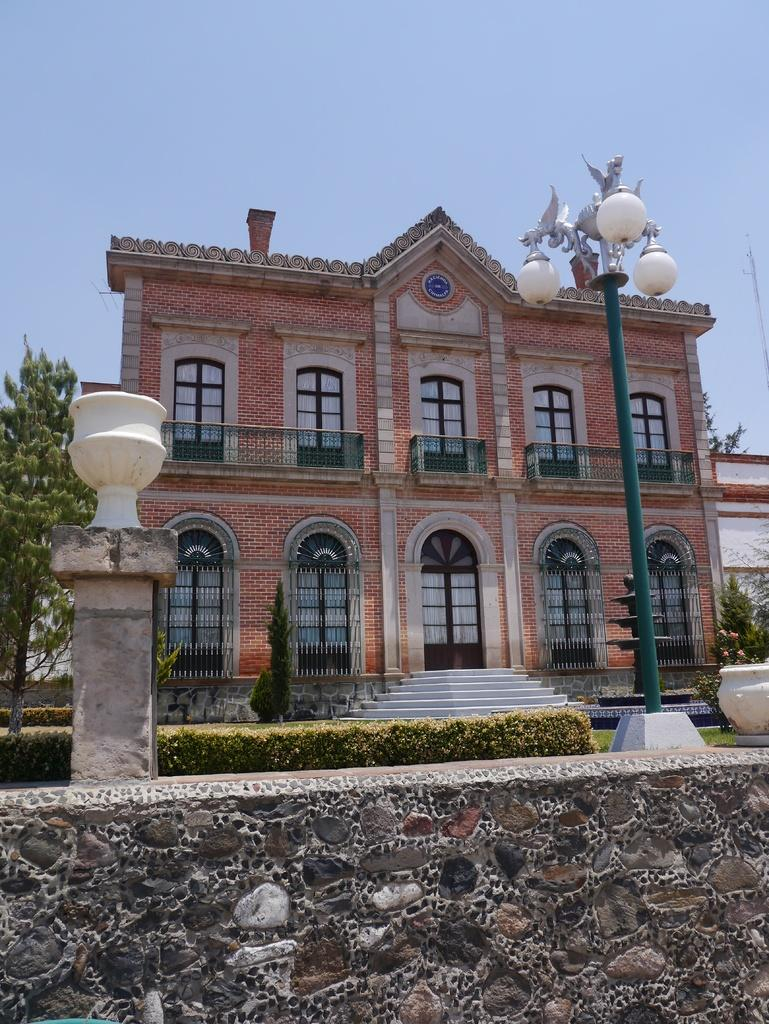What is located at the bottom of the image? There is a wall at the bottom of the image. What can be seen behind the wall? There are plants behind the wall. What other structures are visible in the image? There are poles and a building visible in the image. What type of vegetation is present in the image? There are trees in the image. What is visible at the top of the image? The sky is visible at the top of the image. What is the smell of the yard in the image? There is no yard present in the image, so it is not possible to determine the smell. 